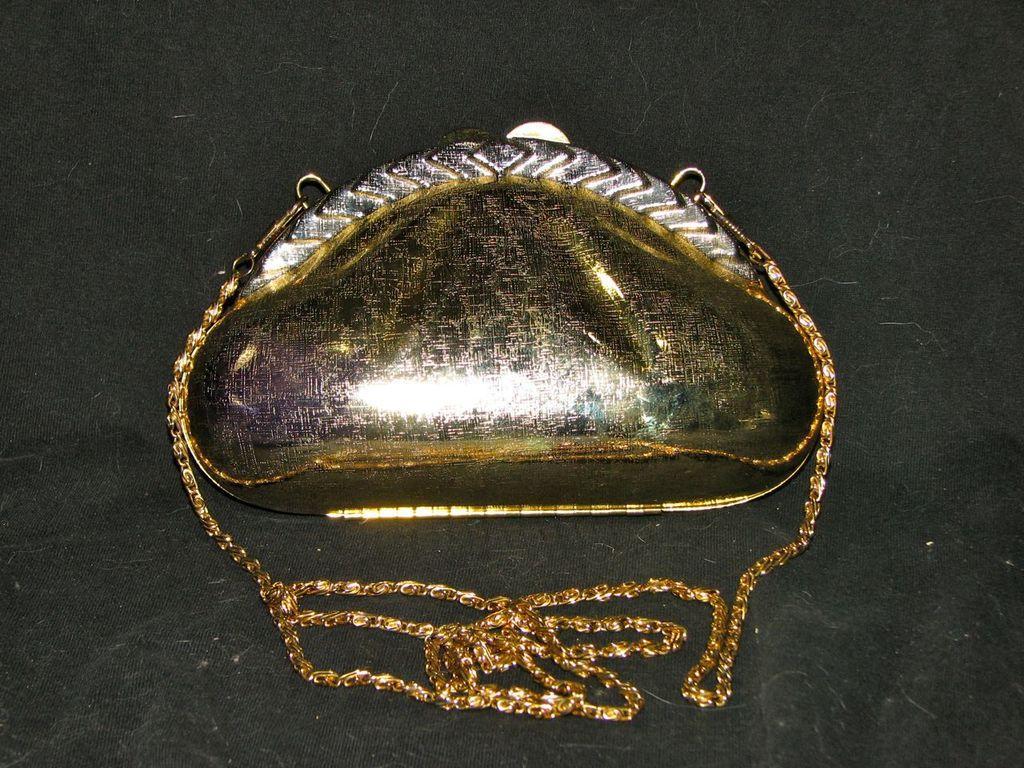How would you summarize this image in a sentence or two? There is a object placed on the black cloth and it has some golden chain attached to it. 